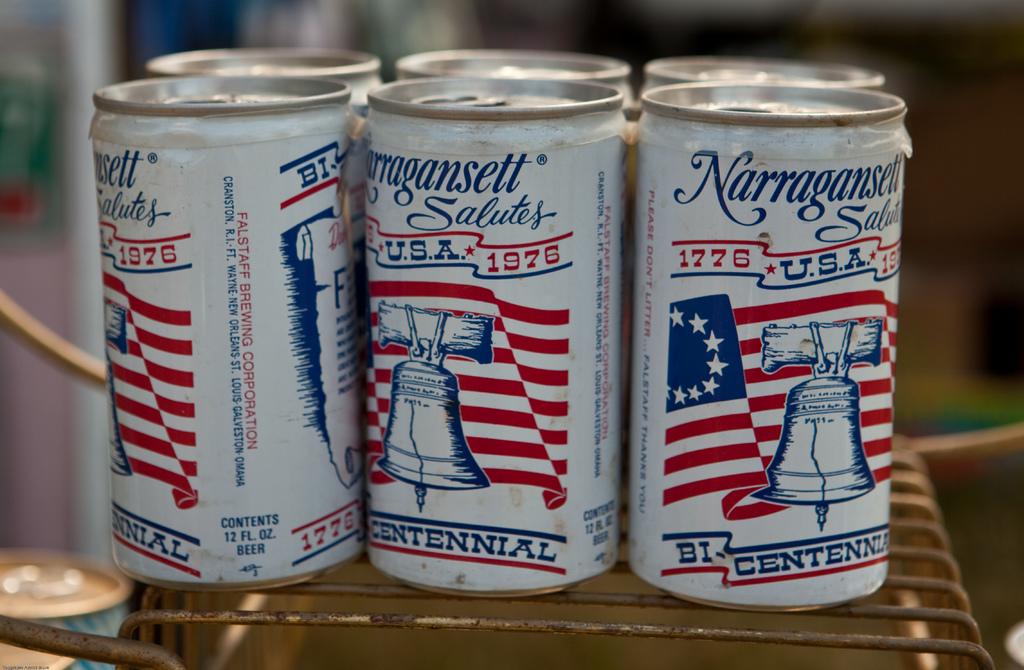What year does it say on the can?
Offer a terse response. 1976. What brand of drink is this?
Provide a succinct answer. Narragansett. 